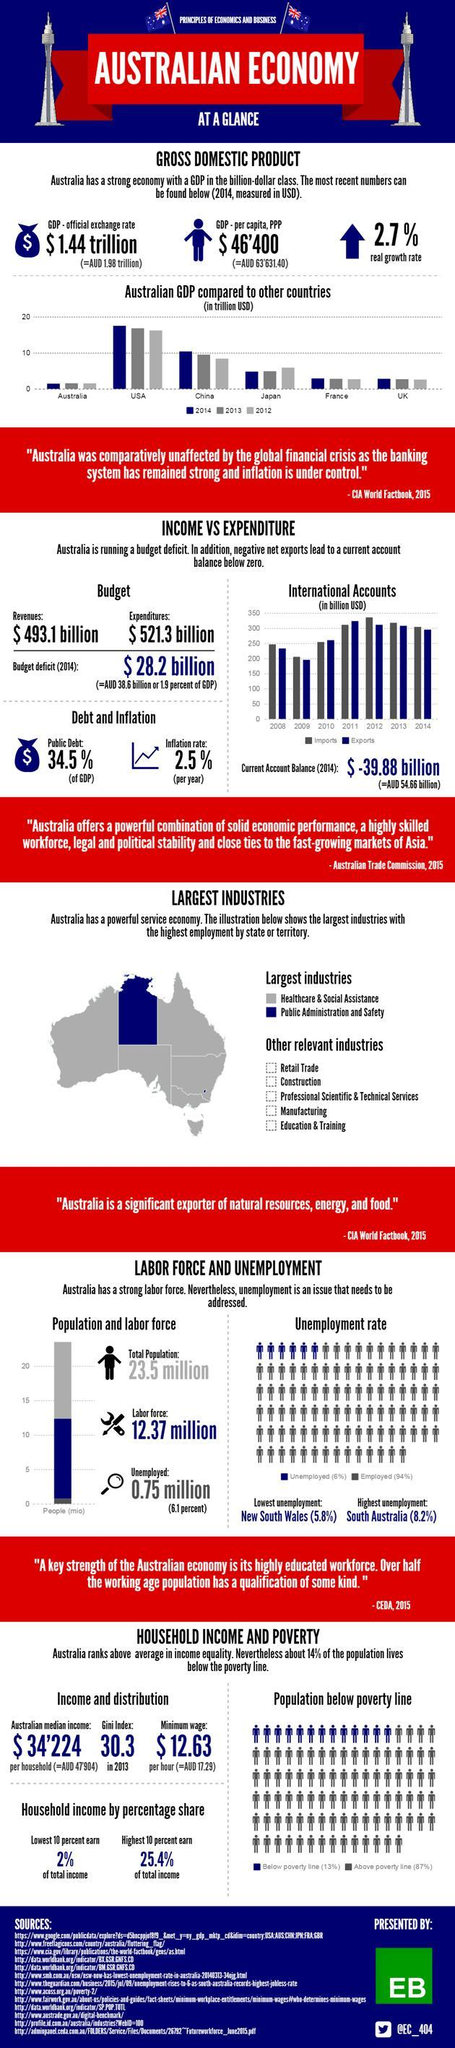How many sources are listed at the bottom?
Answer the question with a short phrase. 13 Which country had the highest GDP in the year 2014 as per the bar chart? USA In which year did the GDP of China reach 10 trillion USD? 2014 What is the Twitter handle mentioned? @EC_404 In which year did the imports reach the maximum under international accounts? 2012 